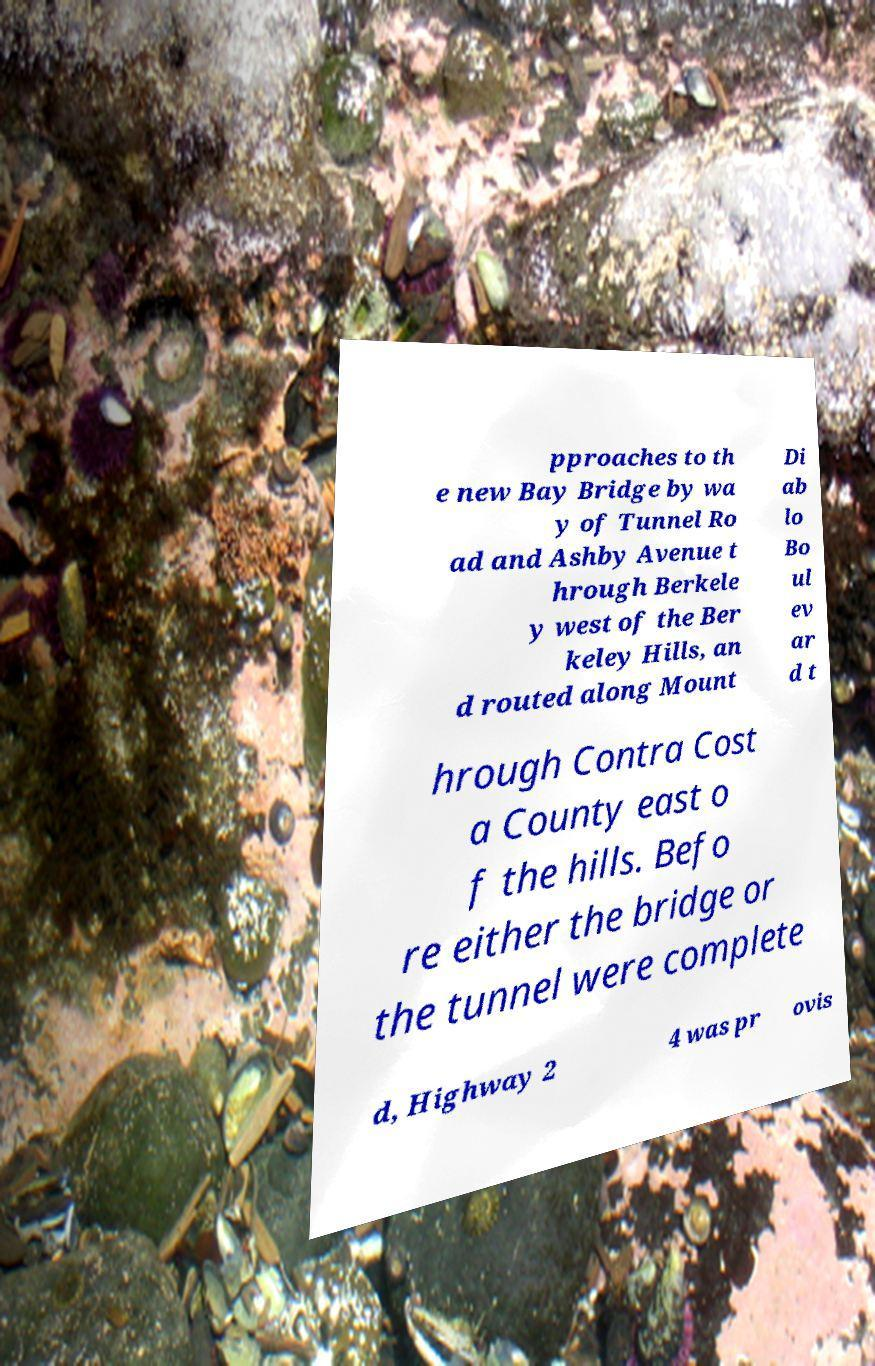What messages or text are displayed in this image? I need them in a readable, typed format. pproaches to th e new Bay Bridge by wa y of Tunnel Ro ad and Ashby Avenue t hrough Berkele y west of the Ber keley Hills, an d routed along Mount Di ab lo Bo ul ev ar d t hrough Contra Cost a County east o f the hills. Befo re either the bridge or the tunnel were complete d, Highway 2 4 was pr ovis 